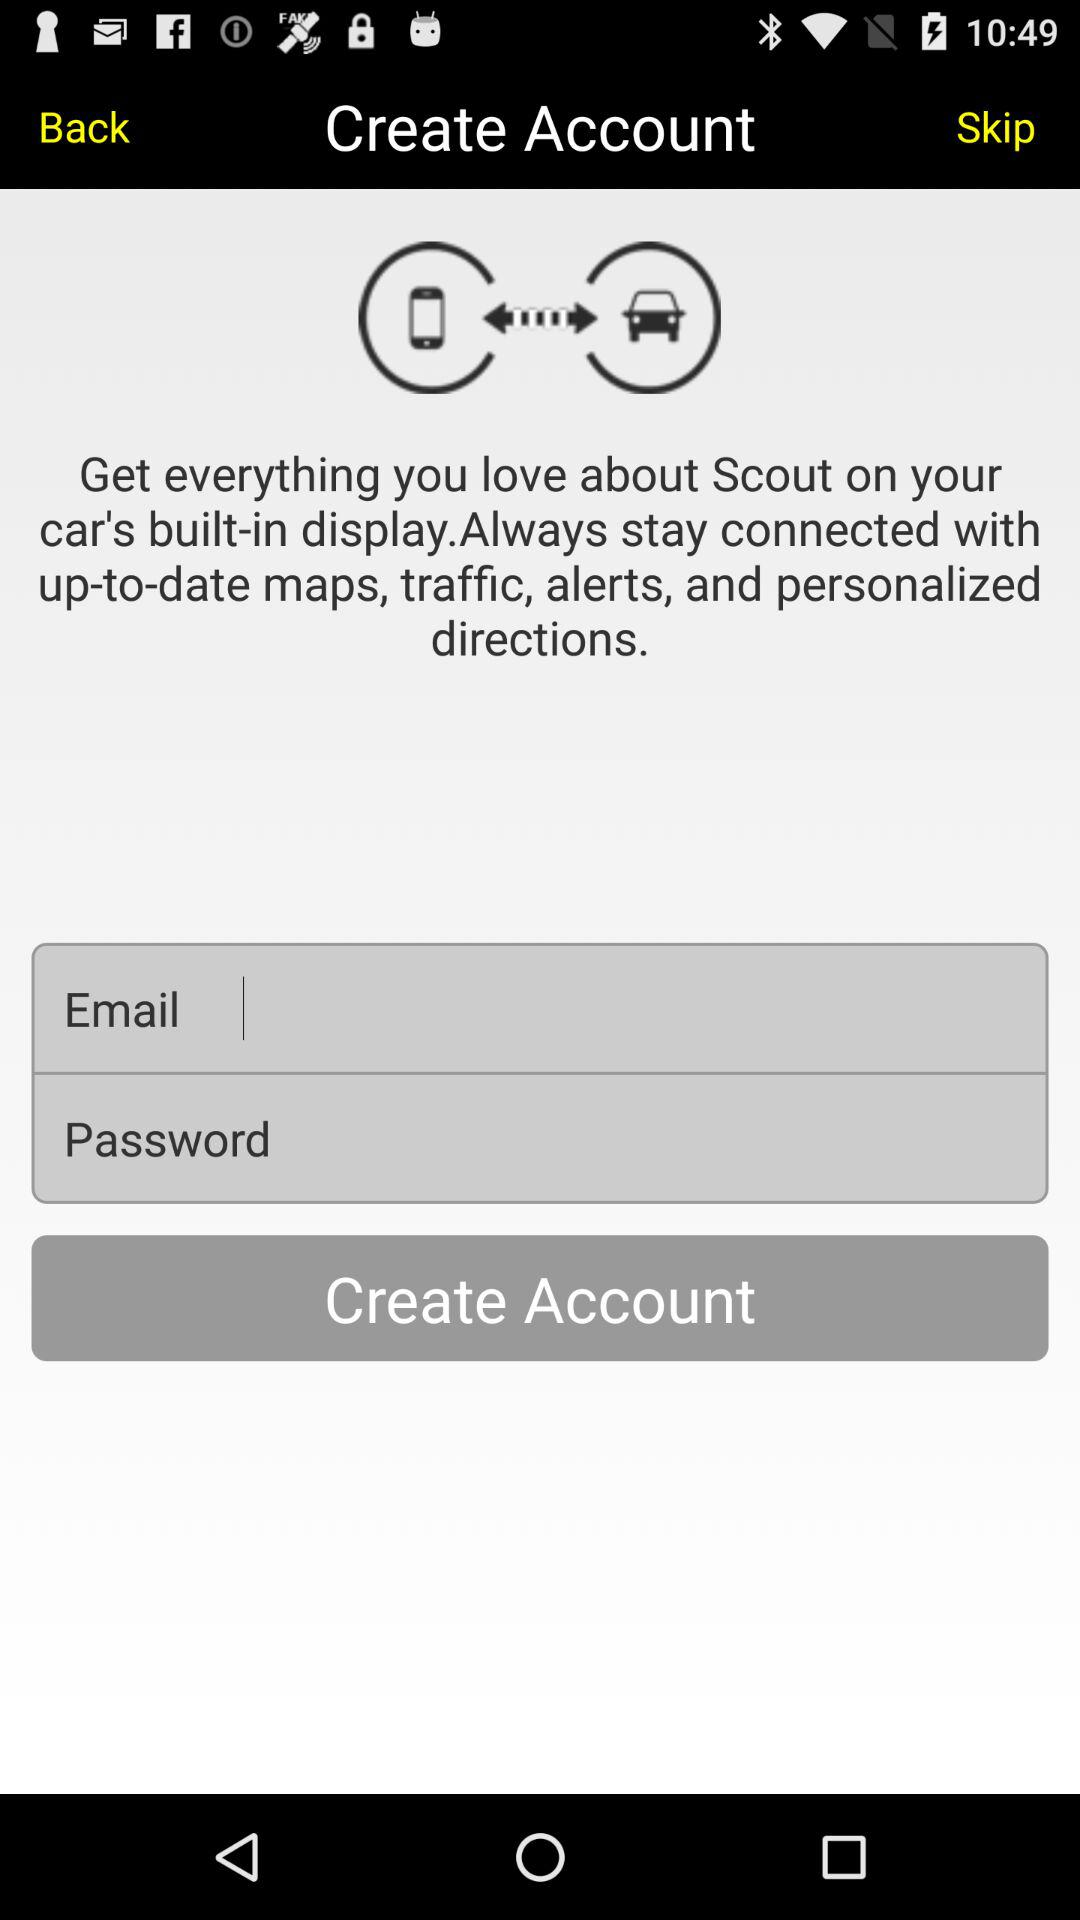What is the email address?
When the provided information is insufficient, respond with <no answer>. <no answer> 